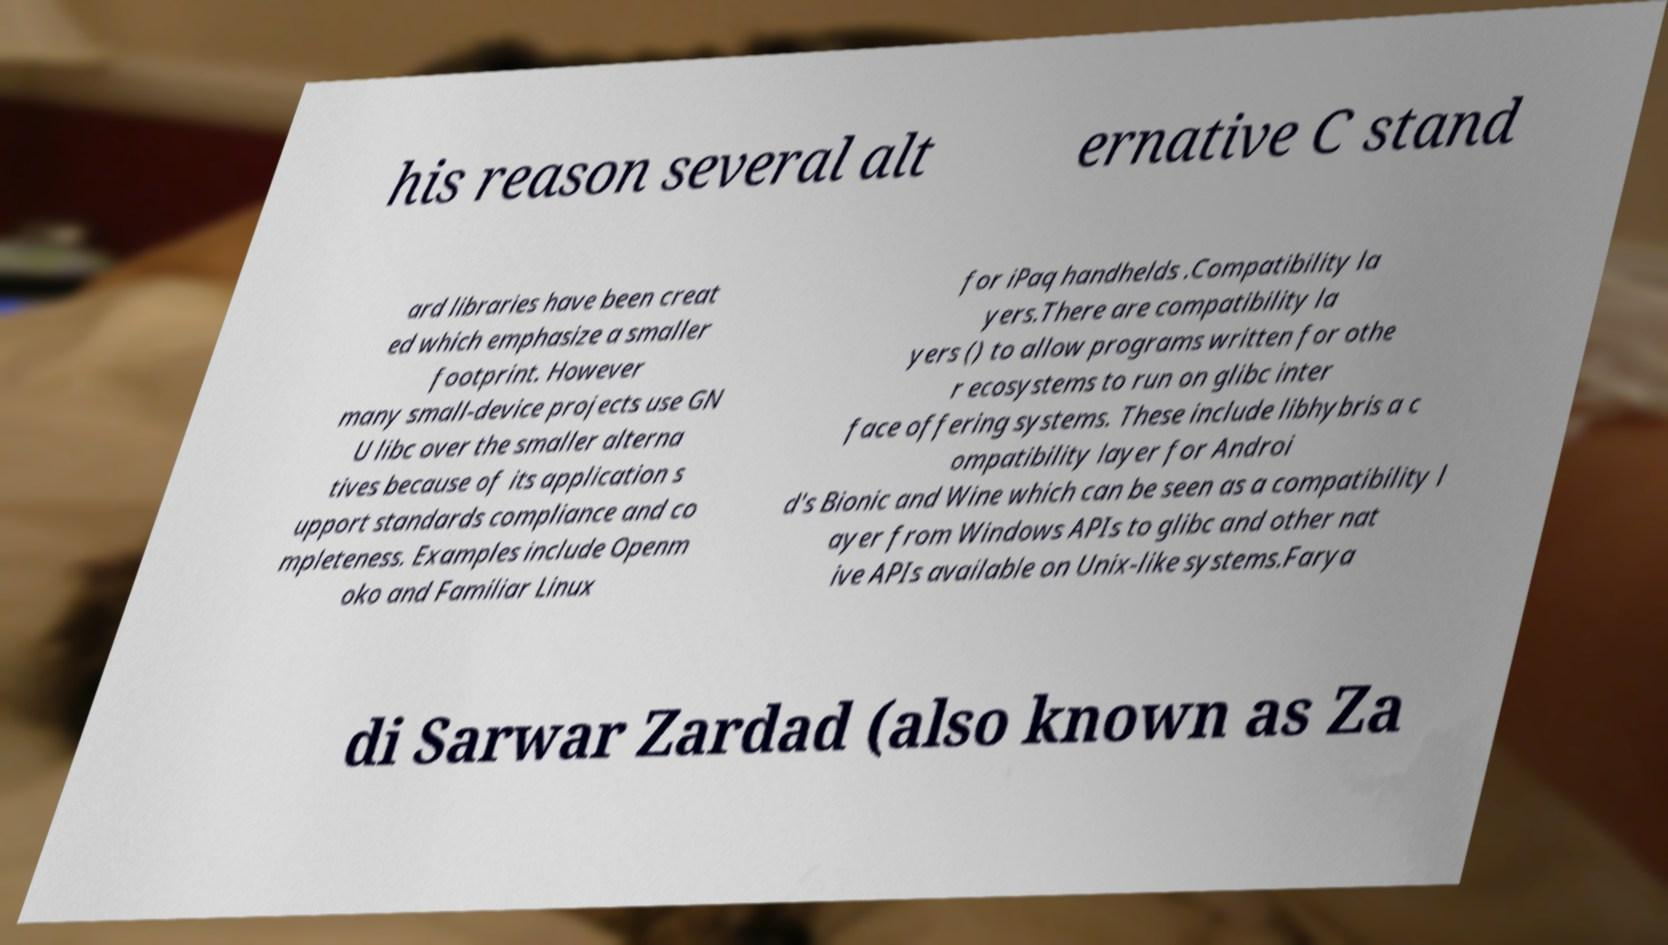Could you extract and type out the text from this image? his reason several alt ernative C stand ard libraries have been creat ed which emphasize a smaller footprint. However many small-device projects use GN U libc over the smaller alterna tives because of its application s upport standards compliance and co mpleteness. Examples include Openm oko and Familiar Linux for iPaq handhelds .Compatibility la yers.There are compatibility la yers () to allow programs written for othe r ecosystems to run on glibc inter face offering systems. These include libhybris a c ompatibility layer for Androi d's Bionic and Wine which can be seen as a compatibility l ayer from Windows APIs to glibc and other nat ive APIs available on Unix-like systems.Farya di Sarwar Zardad (also known as Za 